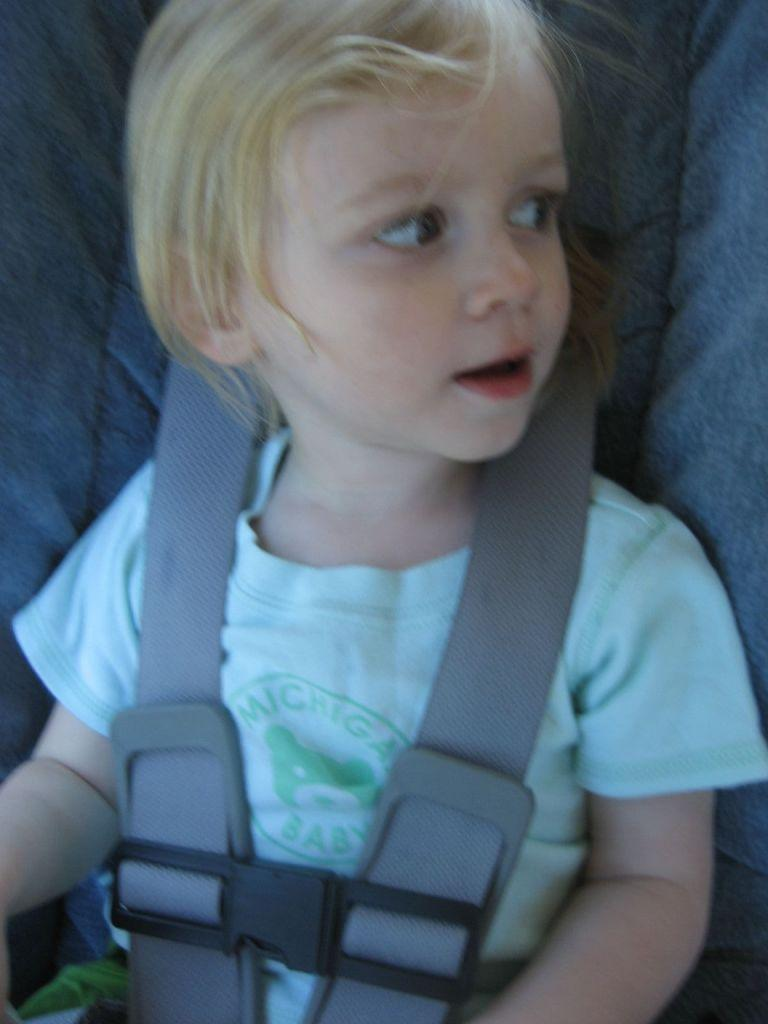What is the main subject of the picture? The main subject of the picture is a kid. What is the kid doing in the picture? The kid is sitting in the picture. Is the kid wearing any safety equipment in the picture? Yes, the kid is wearing a seat belt in the picture. What can be seen on the kid's t-shirt? There is text on the kid's t-shirt. What type of notebook is the kid holding in the picture? There is no notebook present in the picture; the kid is wearing a seat belt and has text on their t-shirt. What kind of oil is visible on the kid's hands in the picture? There is no oil visible on the kid's hands in the picture. 